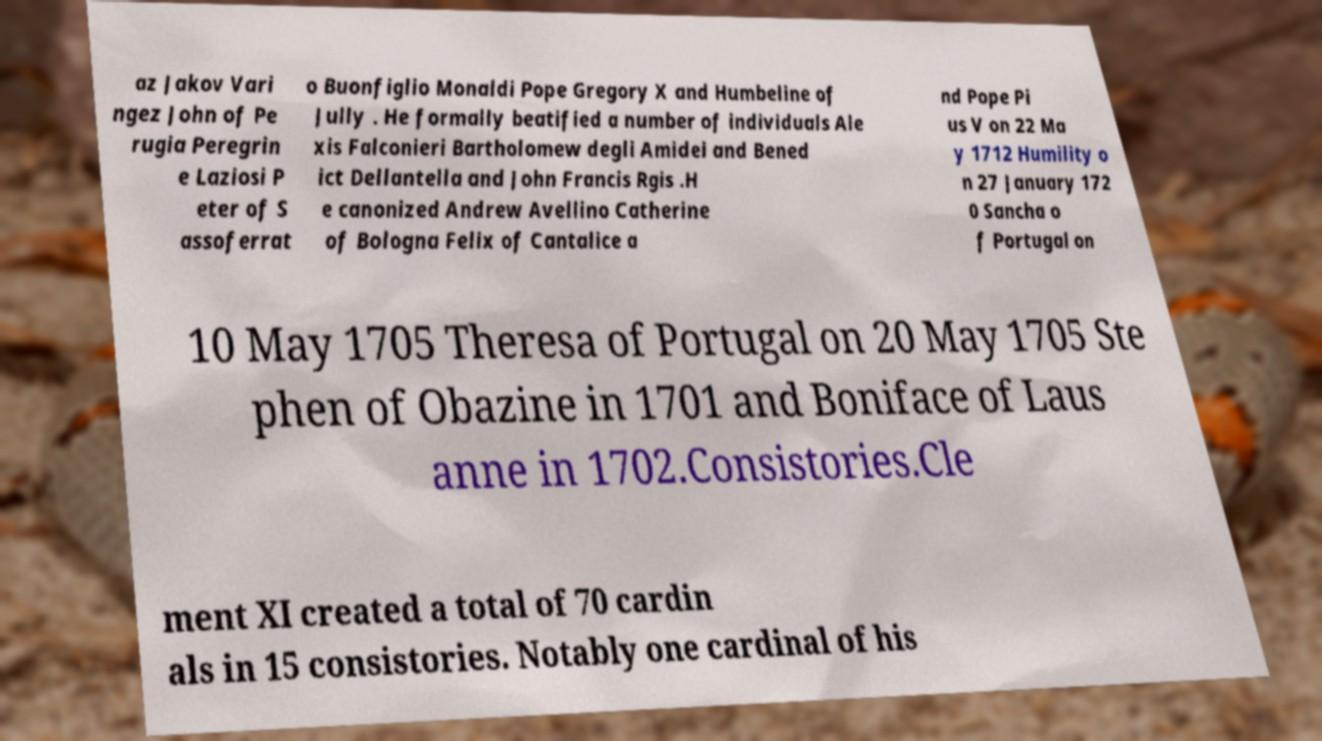Can you read and provide the text displayed in the image?This photo seems to have some interesting text. Can you extract and type it out for me? az Jakov Vari ngez John of Pe rugia Peregrin e Laziosi P eter of S assoferrat o Buonfiglio Monaldi Pope Gregory X and Humbeline of Jully . He formally beatified a number of individuals Ale xis Falconieri Bartholomew degli Amidei and Bened ict Dellantella and John Francis Rgis .H e canonized Andrew Avellino Catherine of Bologna Felix of Cantalice a nd Pope Pi us V on 22 Ma y 1712 Humility o n 27 January 172 0 Sancha o f Portugal on 10 May 1705 Theresa of Portugal on 20 May 1705 Ste phen of Obazine in 1701 and Boniface of Laus anne in 1702.Consistories.Cle ment XI created a total of 70 cardin als in 15 consistories. Notably one cardinal of his 